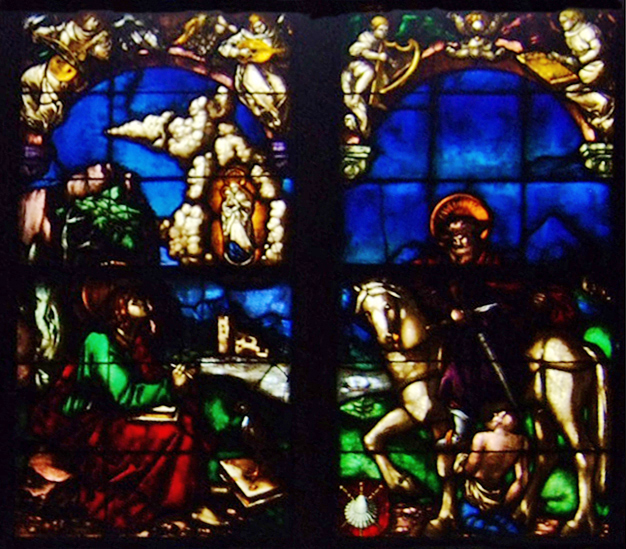What does the architectural style tell us about the window's history or origin? This stained glass window exhibits features of Gothic architecture, recognizable by its pointed arches and intricate tracery. Such elements are typical of the High and Late Medieval periods, primarily found in structures from the 12th to 16th centuries. Gothic architecture was particularly favored for its dramatic and light-enhancing qualities, which made it popular in the construction of cathedrals and churches across Europe. The style emphasizes verticality and the filtering of natural light through colorful glass, which both illuminates and instructs through biblical and saintly narratives. 